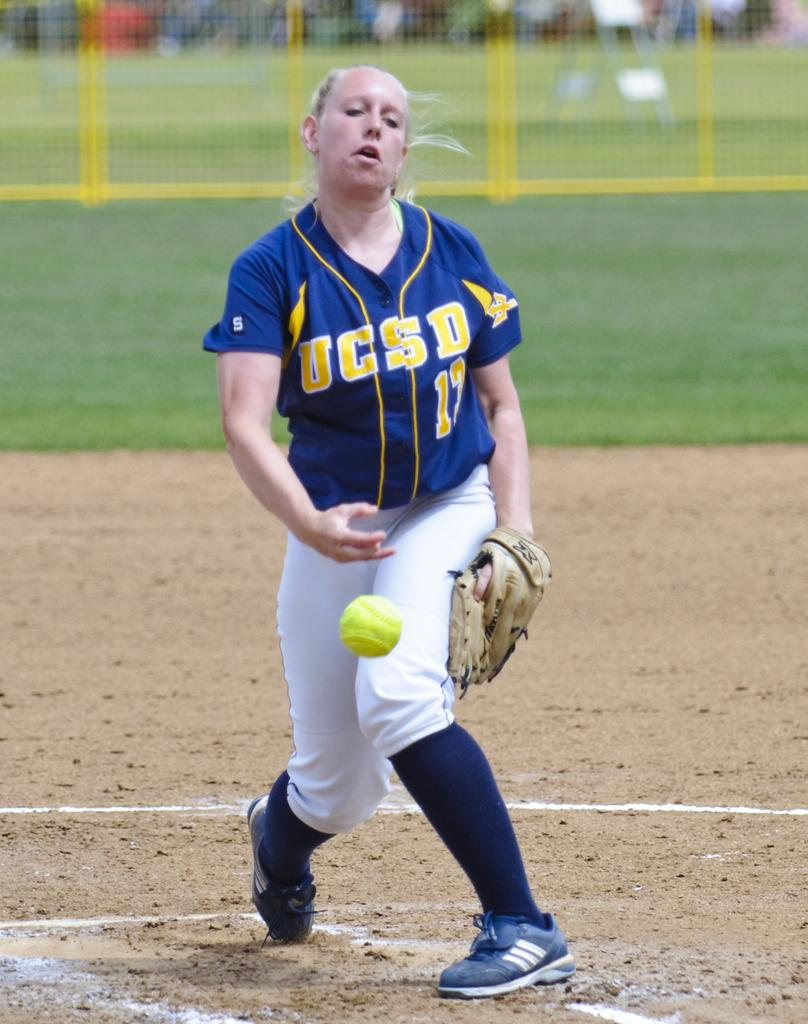<image>
Write a terse but informative summary of the picture. A girl in a UCSD jersey is playing softball. 